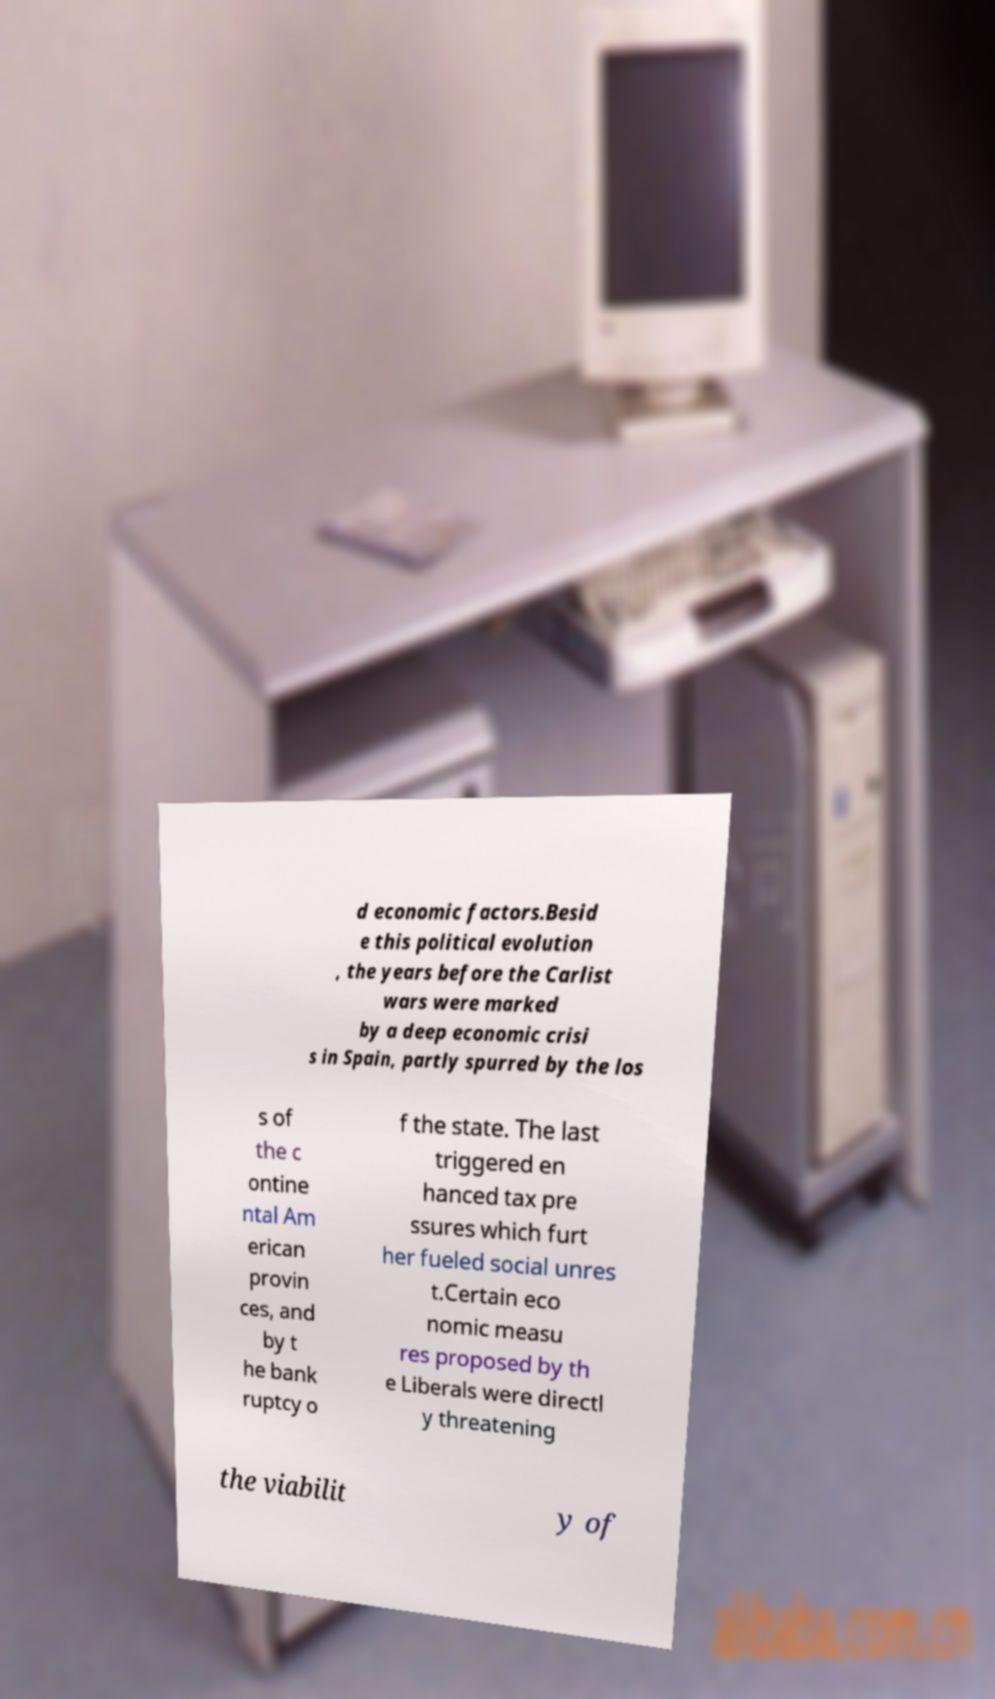I need the written content from this picture converted into text. Can you do that? d economic factors.Besid e this political evolution , the years before the Carlist wars were marked by a deep economic crisi s in Spain, partly spurred by the los s of the c ontine ntal Am erican provin ces, and by t he bank ruptcy o f the state. The last triggered en hanced tax pre ssures which furt her fueled social unres t.Certain eco nomic measu res proposed by th e Liberals were directl y threatening the viabilit y of 